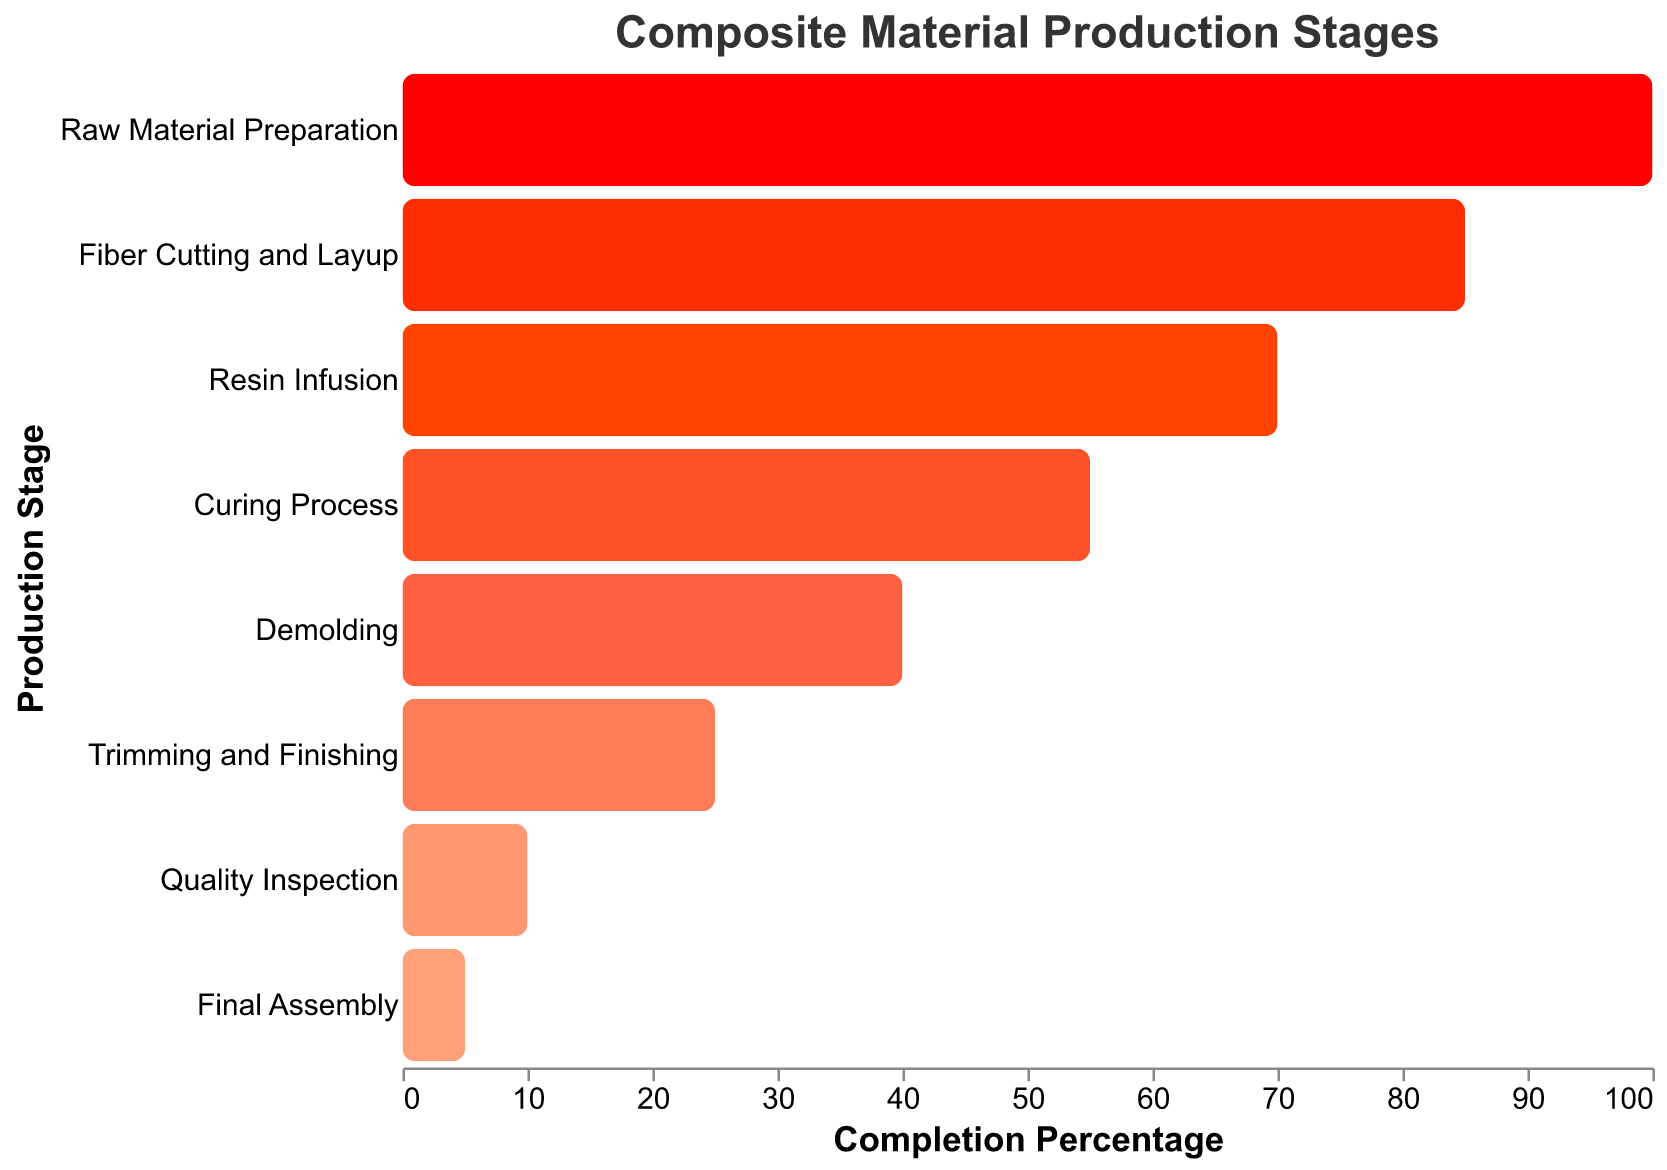What is the title of the chart? The chart title is often at the top and provides a summary of what the chart represents. By looking at the top of the chart, we see the title "Composite Material Production Stages".
Answer: Composite Material Production Stages What does the Y-axis represent? The Y-axis usually represents different categories or stages in a process. In this chart, each stage of the composite material production is listed along the Y-axis.
Answer: Stages of composite material production What stage has the highest completion percentage? Reviewing the bars on the chart, the stage with the longest bar represents the highest completion percentage. "Raw Material Preparation" has the longest bar at 100%.
Answer: Raw Material Preparation Which stage immediately follows "Resin Infusion" in the production process? Looking at the order of stages on the Y-axis, "Curing Process" is listed immediately after "Resin Infusion".
Answer: Curing Process What is the completion percentage difference between "Demolding" and "Curing Process"? To find the difference, subtract the completion percentage of "Demolding" (40%) from that of "Curing Process" (55%). 55% - 40% = 15%.
Answer: 15% Compare the completion percentages of "Trimming and Finishing" and "Quality Inspection". Which stage has a higher percentage and by how much? "Trimming and Finishing" has a 25% completion, while "Quality Inspection" has a 10% completion. Subtract the two percentages: 25% - 10% = 15%. "Trimming and Finishing" has a higher percentage by 15%.
Answer: Trimming and Finishing, 15% How many stages are there in the composite material production process as shown in the chart? Counting the number of distinct stages listed on the Y-axis gives the total number of stages. There are 8 stages listed.
Answer: 8 What's the average completion percentage of all the stages? To find the average, sum all the completion percentages and divide by the number of stages: (100 + 85 + 70 + 55 + 40 + 25 + 10 + 5) / 8 = 390 / 8 = 48.75.
Answer: 48.75% Identify the stage with the lowest completion percentage. The smallest bar on the chart indicates the lowest completion percentage. "Final Assembly" has the smallest bar with 5%.
Answer: Final Assembly Arrange the stages in ascending order of their completion percentages. To arrange the stages from lowest to highest completion percentage: 
1. Final Assembly (5%), 
2. Quality Inspection (10%), 
3. Trimming and Finishing (25%), 
4. Demolding (40%), 
5. Curing Process (55%), 
6. Resin Infusion (70%), 
7. Fiber Cutting and Layup (85%), 
8. Raw Material Preparation (100%).
Answer: Final Assembly, Quality Inspection, Trimming and Finishing, Demolding, Curing Process, Resin Infusion, Fiber Cutting and Layup, Raw Material Preparation 